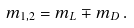Convert formula to latex. <formula><loc_0><loc_0><loc_500><loc_500>m _ { 1 , 2 } = m _ { L } \mp m _ { D } \, .</formula> 